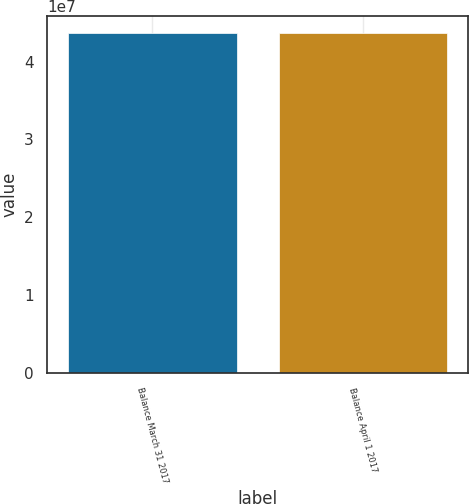Convert chart. <chart><loc_0><loc_0><loc_500><loc_500><bar_chart><fcel>Balance March 31 2017<fcel>Balance April 1 2017<nl><fcel>4.36733e+07<fcel>4.36733e+07<nl></chart> 